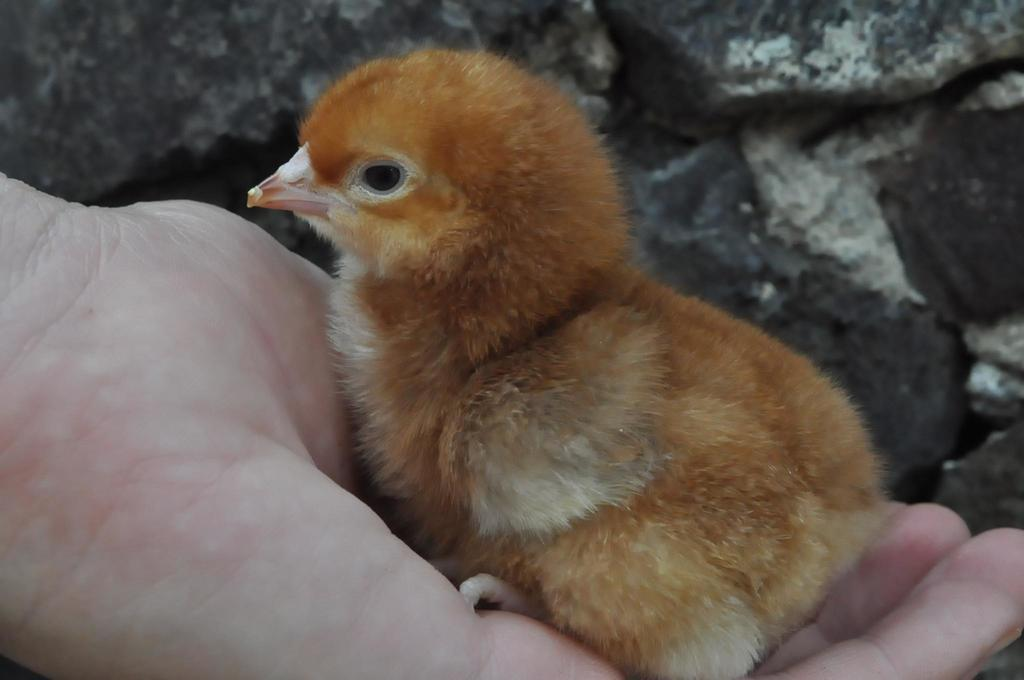What is the person's hand holding in the image? There is a person's hand holding a baby chick in the image. Can you describe the background of the image? There is a rock in the background of the image. How many minutes does it take for the baby chick to swim in the ocean in the image? There is no ocean present in the image, and the baby chick is not swimming. 